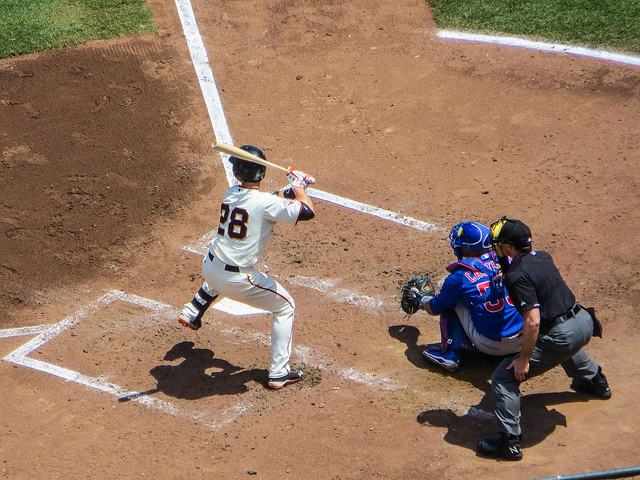Identify the text displayed in this image. 28 